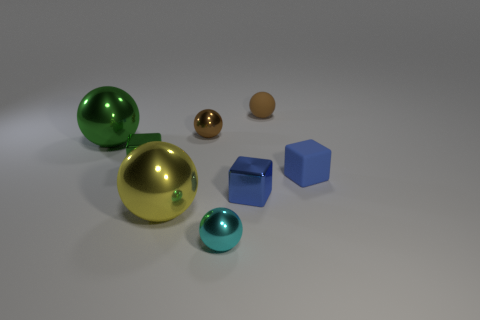Subtract all tiny metal cubes. How many cubes are left? 1 Subtract all brown spheres. How many spheres are left? 3 Subtract all blocks. How many objects are left? 5 Add 1 small green metal cubes. How many objects exist? 9 Subtract 2 blocks. How many blocks are left? 1 Add 4 tiny shiny objects. How many tiny shiny objects are left? 8 Add 8 big green shiny objects. How many big green shiny objects exist? 9 Subtract 0 blue cylinders. How many objects are left? 8 Subtract all cyan spheres. Subtract all brown cubes. How many spheres are left? 4 Subtract all green blocks. How many yellow spheres are left? 1 